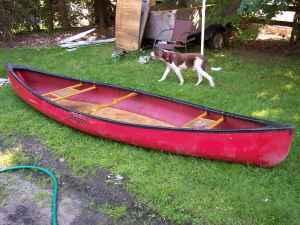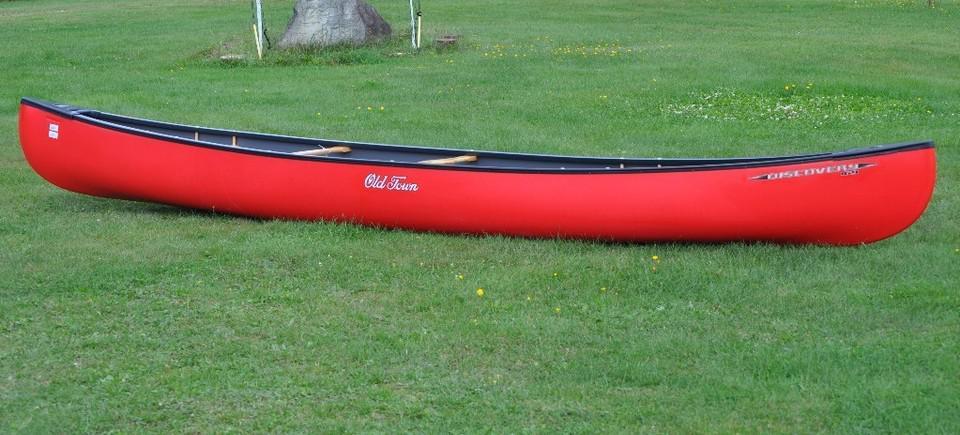The first image is the image on the left, the second image is the image on the right. Analyze the images presented: Is the assertion "There are not human beings visible in at least one image." valid? Answer yes or no. Yes. The first image is the image on the left, the second image is the image on the right. For the images displayed, is the sentence "A boat is floating in water." factually correct? Answer yes or no. No. 